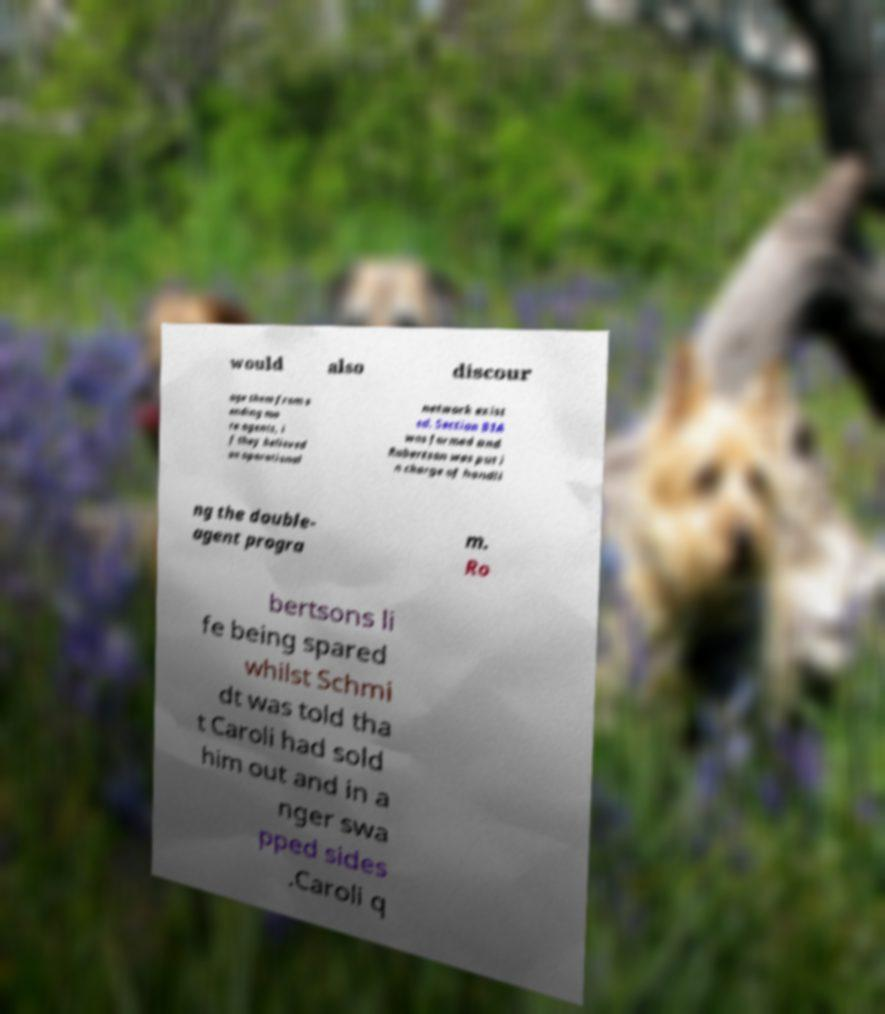For documentation purposes, I need the text within this image transcribed. Could you provide that? would also discour age them from s ending mo re agents, i f they believed an operational network exist ed. Section B1A was formed and Robertson was put i n charge of handli ng the double- agent progra m. Ro bertsons li fe being spared whilst Schmi dt was told tha t Caroli had sold him out and in a nger swa pped sides .Caroli q 